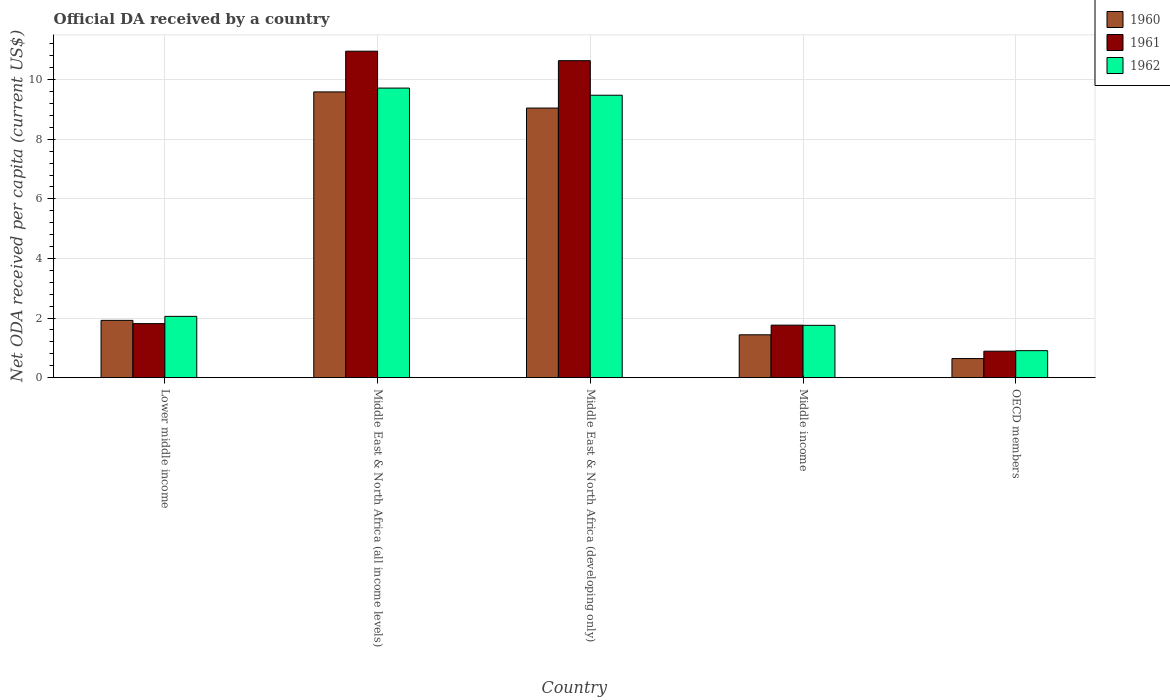How many groups of bars are there?
Ensure brevity in your answer.  5. Are the number of bars per tick equal to the number of legend labels?
Offer a very short reply. Yes. How many bars are there on the 3rd tick from the left?
Give a very brief answer. 3. What is the label of the 1st group of bars from the left?
Provide a succinct answer. Lower middle income. What is the ODA received in in 1961 in Middle East & North Africa (developing only)?
Ensure brevity in your answer.  10.64. Across all countries, what is the maximum ODA received in in 1962?
Provide a short and direct response. 9.72. Across all countries, what is the minimum ODA received in in 1961?
Ensure brevity in your answer.  0.89. In which country was the ODA received in in 1961 maximum?
Provide a succinct answer. Middle East & North Africa (all income levels). In which country was the ODA received in in 1961 minimum?
Your response must be concise. OECD members. What is the total ODA received in in 1962 in the graph?
Offer a terse response. 23.92. What is the difference between the ODA received in in 1960 in Middle East & North Africa (all income levels) and that in Middle income?
Your answer should be compact. 8.15. What is the difference between the ODA received in in 1962 in Middle income and the ODA received in in 1961 in Middle East & North Africa (all income levels)?
Ensure brevity in your answer.  -9.2. What is the average ODA received in in 1961 per country?
Your response must be concise. 5.21. What is the difference between the ODA received in of/in 1961 and ODA received in of/in 1960 in Lower middle income?
Offer a very short reply. -0.11. What is the ratio of the ODA received in in 1961 in Middle East & North Africa (all income levels) to that in Middle income?
Offer a terse response. 6.22. Is the ODA received in in 1961 in Middle East & North Africa (all income levels) less than that in OECD members?
Provide a short and direct response. No. What is the difference between the highest and the second highest ODA received in in 1960?
Provide a succinct answer. 7.67. What is the difference between the highest and the lowest ODA received in in 1961?
Offer a terse response. 10.07. What does the 3rd bar from the right in Middle East & North Africa (all income levels) represents?
Give a very brief answer. 1960. Is it the case that in every country, the sum of the ODA received in in 1960 and ODA received in in 1962 is greater than the ODA received in in 1961?
Your response must be concise. Yes. How many bars are there?
Your answer should be compact. 15. What is the difference between two consecutive major ticks on the Y-axis?
Your response must be concise. 2. Are the values on the major ticks of Y-axis written in scientific E-notation?
Keep it short and to the point. No. Does the graph contain any zero values?
Provide a succinct answer. No. Does the graph contain grids?
Your answer should be very brief. Yes. How many legend labels are there?
Give a very brief answer. 3. How are the legend labels stacked?
Your response must be concise. Vertical. What is the title of the graph?
Ensure brevity in your answer.  Official DA received by a country. What is the label or title of the X-axis?
Your response must be concise. Country. What is the label or title of the Y-axis?
Your answer should be compact. Net ODA received per capita (current US$). What is the Net ODA received per capita (current US$) in 1960 in Lower middle income?
Give a very brief answer. 1.92. What is the Net ODA received per capita (current US$) in 1961 in Lower middle income?
Provide a short and direct response. 1.81. What is the Net ODA received per capita (current US$) in 1962 in Lower middle income?
Provide a short and direct response. 2.06. What is the Net ODA received per capita (current US$) in 1960 in Middle East & North Africa (all income levels)?
Your answer should be compact. 9.59. What is the Net ODA received per capita (current US$) of 1961 in Middle East & North Africa (all income levels)?
Offer a very short reply. 10.96. What is the Net ODA received per capita (current US$) in 1962 in Middle East & North Africa (all income levels)?
Offer a terse response. 9.72. What is the Net ODA received per capita (current US$) in 1960 in Middle East & North Africa (developing only)?
Give a very brief answer. 9.05. What is the Net ODA received per capita (current US$) in 1961 in Middle East & North Africa (developing only)?
Provide a succinct answer. 10.64. What is the Net ODA received per capita (current US$) in 1962 in Middle East & North Africa (developing only)?
Provide a short and direct response. 9.48. What is the Net ODA received per capita (current US$) of 1960 in Middle income?
Ensure brevity in your answer.  1.44. What is the Net ODA received per capita (current US$) of 1961 in Middle income?
Give a very brief answer. 1.76. What is the Net ODA received per capita (current US$) in 1962 in Middle income?
Ensure brevity in your answer.  1.76. What is the Net ODA received per capita (current US$) in 1960 in OECD members?
Keep it short and to the point. 0.64. What is the Net ODA received per capita (current US$) in 1961 in OECD members?
Your answer should be compact. 0.89. What is the Net ODA received per capita (current US$) in 1962 in OECD members?
Offer a terse response. 0.91. Across all countries, what is the maximum Net ODA received per capita (current US$) of 1960?
Keep it short and to the point. 9.59. Across all countries, what is the maximum Net ODA received per capita (current US$) of 1961?
Provide a succinct answer. 10.96. Across all countries, what is the maximum Net ODA received per capita (current US$) of 1962?
Give a very brief answer. 9.72. Across all countries, what is the minimum Net ODA received per capita (current US$) of 1960?
Offer a terse response. 0.64. Across all countries, what is the minimum Net ODA received per capita (current US$) in 1961?
Ensure brevity in your answer.  0.89. Across all countries, what is the minimum Net ODA received per capita (current US$) of 1962?
Give a very brief answer. 0.91. What is the total Net ODA received per capita (current US$) in 1960 in the graph?
Offer a very short reply. 22.64. What is the total Net ODA received per capita (current US$) of 1961 in the graph?
Keep it short and to the point. 26.06. What is the total Net ODA received per capita (current US$) in 1962 in the graph?
Provide a short and direct response. 23.92. What is the difference between the Net ODA received per capita (current US$) of 1960 in Lower middle income and that in Middle East & North Africa (all income levels)?
Your answer should be very brief. -7.67. What is the difference between the Net ODA received per capita (current US$) in 1961 in Lower middle income and that in Middle East & North Africa (all income levels)?
Offer a very short reply. -9.14. What is the difference between the Net ODA received per capita (current US$) in 1962 in Lower middle income and that in Middle East & North Africa (all income levels)?
Your response must be concise. -7.66. What is the difference between the Net ODA received per capita (current US$) in 1960 in Lower middle income and that in Middle East & North Africa (developing only)?
Your answer should be compact. -7.13. What is the difference between the Net ODA received per capita (current US$) in 1961 in Lower middle income and that in Middle East & North Africa (developing only)?
Provide a short and direct response. -8.82. What is the difference between the Net ODA received per capita (current US$) in 1962 in Lower middle income and that in Middle East & North Africa (developing only)?
Your response must be concise. -7.42. What is the difference between the Net ODA received per capita (current US$) in 1960 in Lower middle income and that in Middle income?
Your answer should be very brief. 0.48. What is the difference between the Net ODA received per capita (current US$) in 1961 in Lower middle income and that in Middle income?
Offer a terse response. 0.05. What is the difference between the Net ODA received per capita (current US$) in 1962 in Lower middle income and that in Middle income?
Provide a succinct answer. 0.3. What is the difference between the Net ODA received per capita (current US$) of 1960 in Lower middle income and that in OECD members?
Keep it short and to the point. 1.28. What is the difference between the Net ODA received per capita (current US$) in 1961 in Lower middle income and that in OECD members?
Make the answer very short. 0.92. What is the difference between the Net ODA received per capita (current US$) in 1962 in Lower middle income and that in OECD members?
Make the answer very short. 1.15. What is the difference between the Net ODA received per capita (current US$) of 1960 in Middle East & North Africa (all income levels) and that in Middle East & North Africa (developing only)?
Ensure brevity in your answer.  0.54. What is the difference between the Net ODA received per capita (current US$) in 1961 in Middle East & North Africa (all income levels) and that in Middle East & North Africa (developing only)?
Offer a very short reply. 0.32. What is the difference between the Net ODA received per capita (current US$) in 1962 in Middle East & North Africa (all income levels) and that in Middle East & North Africa (developing only)?
Offer a terse response. 0.24. What is the difference between the Net ODA received per capita (current US$) of 1960 in Middle East & North Africa (all income levels) and that in Middle income?
Offer a very short reply. 8.15. What is the difference between the Net ODA received per capita (current US$) in 1961 in Middle East & North Africa (all income levels) and that in Middle income?
Offer a very short reply. 9.19. What is the difference between the Net ODA received per capita (current US$) in 1962 in Middle East & North Africa (all income levels) and that in Middle income?
Provide a succinct answer. 7.96. What is the difference between the Net ODA received per capita (current US$) of 1960 in Middle East & North Africa (all income levels) and that in OECD members?
Give a very brief answer. 8.95. What is the difference between the Net ODA received per capita (current US$) in 1961 in Middle East & North Africa (all income levels) and that in OECD members?
Ensure brevity in your answer.  10.07. What is the difference between the Net ODA received per capita (current US$) in 1962 in Middle East & North Africa (all income levels) and that in OECD members?
Offer a terse response. 8.81. What is the difference between the Net ODA received per capita (current US$) in 1960 in Middle East & North Africa (developing only) and that in Middle income?
Your answer should be very brief. 7.61. What is the difference between the Net ODA received per capita (current US$) of 1961 in Middle East & North Africa (developing only) and that in Middle income?
Give a very brief answer. 8.88. What is the difference between the Net ODA received per capita (current US$) of 1962 in Middle East & North Africa (developing only) and that in Middle income?
Offer a terse response. 7.72. What is the difference between the Net ODA received per capita (current US$) of 1960 in Middle East & North Africa (developing only) and that in OECD members?
Your answer should be compact. 8.41. What is the difference between the Net ODA received per capita (current US$) in 1961 in Middle East & North Africa (developing only) and that in OECD members?
Your answer should be very brief. 9.75. What is the difference between the Net ODA received per capita (current US$) of 1962 in Middle East & North Africa (developing only) and that in OECD members?
Your answer should be very brief. 8.57. What is the difference between the Net ODA received per capita (current US$) in 1960 in Middle income and that in OECD members?
Keep it short and to the point. 0.8. What is the difference between the Net ODA received per capita (current US$) of 1961 in Middle income and that in OECD members?
Your response must be concise. 0.87. What is the difference between the Net ODA received per capita (current US$) in 1962 in Middle income and that in OECD members?
Provide a succinct answer. 0.85. What is the difference between the Net ODA received per capita (current US$) of 1960 in Lower middle income and the Net ODA received per capita (current US$) of 1961 in Middle East & North Africa (all income levels)?
Make the answer very short. -9.03. What is the difference between the Net ODA received per capita (current US$) in 1960 in Lower middle income and the Net ODA received per capita (current US$) in 1962 in Middle East & North Africa (all income levels)?
Keep it short and to the point. -7.8. What is the difference between the Net ODA received per capita (current US$) of 1961 in Lower middle income and the Net ODA received per capita (current US$) of 1962 in Middle East & North Africa (all income levels)?
Offer a terse response. -7.9. What is the difference between the Net ODA received per capita (current US$) in 1960 in Lower middle income and the Net ODA received per capita (current US$) in 1961 in Middle East & North Africa (developing only)?
Make the answer very short. -8.72. What is the difference between the Net ODA received per capita (current US$) in 1960 in Lower middle income and the Net ODA received per capita (current US$) in 1962 in Middle East & North Africa (developing only)?
Provide a short and direct response. -7.56. What is the difference between the Net ODA received per capita (current US$) of 1961 in Lower middle income and the Net ODA received per capita (current US$) of 1962 in Middle East & North Africa (developing only)?
Make the answer very short. -7.67. What is the difference between the Net ODA received per capita (current US$) of 1960 in Lower middle income and the Net ODA received per capita (current US$) of 1961 in Middle income?
Your response must be concise. 0.16. What is the difference between the Net ODA received per capita (current US$) of 1960 in Lower middle income and the Net ODA received per capita (current US$) of 1962 in Middle income?
Provide a succinct answer. 0.17. What is the difference between the Net ODA received per capita (current US$) of 1961 in Lower middle income and the Net ODA received per capita (current US$) of 1962 in Middle income?
Provide a short and direct response. 0.06. What is the difference between the Net ODA received per capita (current US$) of 1960 in Lower middle income and the Net ODA received per capita (current US$) of 1961 in OECD members?
Your answer should be very brief. 1.03. What is the difference between the Net ODA received per capita (current US$) in 1960 in Lower middle income and the Net ODA received per capita (current US$) in 1962 in OECD members?
Give a very brief answer. 1.02. What is the difference between the Net ODA received per capita (current US$) of 1961 in Lower middle income and the Net ODA received per capita (current US$) of 1962 in OECD members?
Make the answer very short. 0.91. What is the difference between the Net ODA received per capita (current US$) in 1960 in Middle East & North Africa (all income levels) and the Net ODA received per capita (current US$) in 1961 in Middle East & North Africa (developing only)?
Make the answer very short. -1.05. What is the difference between the Net ODA received per capita (current US$) in 1960 in Middle East & North Africa (all income levels) and the Net ODA received per capita (current US$) in 1962 in Middle East & North Africa (developing only)?
Offer a terse response. 0.11. What is the difference between the Net ODA received per capita (current US$) of 1961 in Middle East & North Africa (all income levels) and the Net ODA received per capita (current US$) of 1962 in Middle East & North Africa (developing only)?
Make the answer very short. 1.48. What is the difference between the Net ODA received per capita (current US$) in 1960 in Middle East & North Africa (all income levels) and the Net ODA received per capita (current US$) in 1961 in Middle income?
Make the answer very short. 7.83. What is the difference between the Net ODA received per capita (current US$) of 1960 in Middle East & North Africa (all income levels) and the Net ODA received per capita (current US$) of 1962 in Middle income?
Make the answer very short. 7.83. What is the difference between the Net ODA received per capita (current US$) of 1961 in Middle East & North Africa (all income levels) and the Net ODA received per capita (current US$) of 1962 in Middle income?
Offer a terse response. 9.2. What is the difference between the Net ODA received per capita (current US$) of 1960 in Middle East & North Africa (all income levels) and the Net ODA received per capita (current US$) of 1961 in OECD members?
Give a very brief answer. 8.7. What is the difference between the Net ODA received per capita (current US$) of 1960 in Middle East & North Africa (all income levels) and the Net ODA received per capita (current US$) of 1962 in OECD members?
Ensure brevity in your answer.  8.68. What is the difference between the Net ODA received per capita (current US$) of 1961 in Middle East & North Africa (all income levels) and the Net ODA received per capita (current US$) of 1962 in OECD members?
Your response must be concise. 10.05. What is the difference between the Net ODA received per capita (current US$) of 1960 in Middle East & North Africa (developing only) and the Net ODA received per capita (current US$) of 1961 in Middle income?
Give a very brief answer. 7.29. What is the difference between the Net ODA received per capita (current US$) in 1960 in Middle East & North Africa (developing only) and the Net ODA received per capita (current US$) in 1962 in Middle income?
Your response must be concise. 7.29. What is the difference between the Net ODA received per capita (current US$) in 1961 in Middle East & North Africa (developing only) and the Net ODA received per capita (current US$) in 1962 in Middle income?
Make the answer very short. 8.88. What is the difference between the Net ODA received per capita (current US$) of 1960 in Middle East & North Africa (developing only) and the Net ODA received per capita (current US$) of 1961 in OECD members?
Provide a succinct answer. 8.16. What is the difference between the Net ODA received per capita (current US$) of 1960 in Middle East & North Africa (developing only) and the Net ODA received per capita (current US$) of 1962 in OECD members?
Offer a very short reply. 8.14. What is the difference between the Net ODA received per capita (current US$) in 1961 in Middle East & North Africa (developing only) and the Net ODA received per capita (current US$) in 1962 in OECD members?
Give a very brief answer. 9.73. What is the difference between the Net ODA received per capita (current US$) of 1960 in Middle income and the Net ODA received per capita (current US$) of 1961 in OECD members?
Provide a short and direct response. 0.55. What is the difference between the Net ODA received per capita (current US$) in 1960 in Middle income and the Net ODA received per capita (current US$) in 1962 in OECD members?
Make the answer very short. 0.53. What is the difference between the Net ODA received per capita (current US$) in 1961 in Middle income and the Net ODA received per capita (current US$) in 1962 in OECD members?
Make the answer very short. 0.86. What is the average Net ODA received per capita (current US$) in 1960 per country?
Provide a succinct answer. 4.53. What is the average Net ODA received per capita (current US$) in 1961 per country?
Your answer should be compact. 5.21. What is the average Net ODA received per capita (current US$) of 1962 per country?
Make the answer very short. 4.78. What is the difference between the Net ODA received per capita (current US$) in 1960 and Net ODA received per capita (current US$) in 1961 in Lower middle income?
Your response must be concise. 0.11. What is the difference between the Net ODA received per capita (current US$) in 1960 and Net ODA received per capita (current US$) in 1962 in Lower middle income?
Offer a terse response. -0.13. What is the difference between the Net ODA received per capita (current US$) of 1961 and Net ODA received per capita (current US$) of 1962 in Lower middle income?
Offer a very short reply. -0.24. What is the difference between the Net ODA received per capita (current US$) of 1960 and Net ODA received per capita (current US$) of 1961 in Middle East & North Africa (all income levels)?
Provide a short and direct response. -1.37. What is the difference between the Net ODA received per capita (current US$) in 1960 and Net ODA received per capita (current US$) in 1962 in Middle East & North Africa (all income levels)?
Give a very brief answer. -0.13. What is the difference between the Net ODA received per capita (current US$) in 1961 and Net ODA received per capita (current US$) in 1962 in Middle East & North Africa (all income levels)?
Make the answer very short. 1.24. What is the difference between the Net ODA received per capita (current US$) of 1960 and Net ODA received per capita (current US$) of 1961 in Middle East & North Africa (developing only)?
Provide a succinct answer. -1.59. What is the difference between the Net ODA received per capita (current US$) in 1960 and Net ODA received per capita (current US$) in 1962 in Middle East & North Africa (developing only)?
Your answer should be very brief. -0.43. What is the difference between the Net ODA received per capita (current US$) of 1961 and Net ODA received per capita (current US$) of 1962 in Middle East & North Africa (developing only)?
Your answer should be very brief. 1.16. What is the difference between the Net ODA received per capita (current US$) of 1960 and Net ODA received per capita (current US$) of 1961 in Middle income?
Make the answer very short. -0.32. What is the difference between the Net ODA received per capita (current US$) of 1960 and Net ODA received per capita (current US$) of 1962 in Middle income?
Offer a very short reply. -0.32. What is the difference between the Net ODA received per capita (current US$) in 1961 and Net ODA received per capita (current US$) in 1962 in Middle income?
Give a very brief answer. 0.01. What is the difference between the Net ODA received per capita (current US$) of 1960 and Net ODA received per capita (current US$) of 1961 in OECD members?
Offer a very short reply. -0.25. What is the difference between the Net ODA received per capita (current US$) in 1960 and Net ODA received per capita (current US$) in 1962 in OECD members?
Make the answer very short. -0.27. What is the difference between the Net ODA received per capita (current US$) of 1961 and Net ODA received per capita (current US$) of 1962 in OECD members?
Make the answer very short. -0.02. What is the ratio of the Net ODA received per capita (current US$) in 1960 in Lower middle income to that in Middle East & North Africa (all income levels)?
Provide a short and direct response. 0.2. What is the ratio of the Net ODA received per capita (current US$) of 1961 in Lower middle income to that in Middle East & North Africa (all income levels)?
Your response must be concise. 0.17. What is the ratio of the Net ODA received per capita (current US$) of 1962 in Lower middle income to that in Middle East & North Africa (all income levels)?
Your response must be concise. 0.21. What is the ratio of the Net ODA received per capita (current US$) of 1960 in Lower middle income to that in Middle East & North Africa (developing only)?
Give a very brief answer. 0.21. What is the ratio of the Net ODA received per capita (current US$) in 1961 in Lower middle income to that in Middle East & North Africa (developing only)?
Your answer should be very brief. 0.17. What is the ratio of the Net ODA received per capita (current US$) of 1962 in Lower middle income to that in Middle East & North Africa (developing only)?
Ensure brevity in your answer.  0.22. What is the ratio of the Net ODA received per capita (current US$) of 1960 in Lower middle income to that in Middle income?
Give a very brief answer. 1.34. What is the ratio of the Net ODA received per capita (current US$) in 1961 in Lower middle income to that in Middle income?
Give a very brief answer. 1.03. What is the ratio of the Net ODA received per capita (current US$) of 1962 in Lower middle income to that in Middle income?
Make the answer very short. 1.17. What is the ratio of the Net ODA received per capita (current US$) in 1960 in Lower middle income to that in OECD members?
Ensure brevity in your answer.  3. What is the ratio of the Net ODA received per capita (current US$) of 1961 in Lower middle income to that in OECD members?
Give a very brief answer. 2.04. What is the ratio of the Net ODA received per capita (current US$) of 1962 in Lower middle income to that in OECD members?
Make the answer very short. 2.27. What is the ratio of the Net ODA received per capita (current US$) of 1960 in Middle East & North Africa (all income levels) to that in Middle East & North Africa (developing only)?
Your answer should be very brief. 1.06. What is the ratio of the Net ODA received per capita (current US$) in 1961 in Middle East & North Africa (all income levels) to that in Middle East & North Africa (developing only)?
Keep it short and to the point. 1.03. What is the ratio of the Net ODA received per capita (current US$) in 1962 in Middle East & North Africa (all income levels) to that in Middle East & North Africa (developing only)?
Provide a succinct answer. 1.03. What is the ratio of the Net ODA received per capita (current US$) of 1960 in Middle East & North Africa (all income levels) to that in Middle income?
Provide a short and direct response. 6.67. What is the ratio of the Net ODA received per capita (current US$) of 1961 in Middle East & North Africa (all income levels) to that in Middle income?
Your answer should be compact. 6.22. What is the ratio of the Net ODA received per capita (current US$) of 1962 in Middle East & North Africa (all income levels) to that in Middle income?
Provide a short and direct response. 5.53. What is the ratio of the Net ODA received per capita (current US$) of 1960 in Middle East & North Africa (all income levels) to that in OECD members?
Your response must be concise. 14.96. What is the ratio of the Net ODA received per capita (current US$) in 1961 in Middle East & North Africa (all income levels) to that in OECD members?
Your response must be concise. 12.33. What is the ratio of the Net ODA received per capita (current US$) in 1962 in Middle East & North Africa (all income levels) to that in OECD members?
Keep it short and to the point. 10.72. What is the ratio of the Net ODA received per capita (current US$) of 1960 in Middle East & North Africa (developing only) to that in Middle income?
Offer a very short reply. 6.29. What is the ratio of the Net ODA received per capita (current US$) of 1961 in Middle East & North Africa (developing only) to that in Middle income?
Offer a terse response. 6.04. What is the ratio of the Net ODA received per capita (current US$) in 1962 in Middle East & North Africa (developing only) to that in Middle income?
Provide a short and direct response. 5.4. What is the ratio of the Net ODA received per capita (current US$) of 1960 in Middle East & North Africa (developing only) to that in OECD members?
Provide a short and direct response. 14.12. What is the ratio of the Net ODA received per capita (current US$) in 1961 in Middle East & North Africa (developing only) to that in OECD members?
Your response must be concise. 11.97. What is the ratio of the Net ODA received per capita (current US$) in 1962 in Middle East & North Africa (developing only) to that in OECD members?
Ensure brevity in your answer.  10.46. What is the ratio of the Net ODA received per capita (current US$) in 1960 in Middle income to that in OECD members?
Give a very brief answer. 2.24. What is the ratio of the Net ODA received per capita (current US$) in 1961 in Middle income to that in OECD members?
Make the answer very short. 1.98. What is the ratio of the Net ODA received per capita (current US$) of 1962 in Middle income to that in OECD members?
Your response must be concise. 1.94. What is the difference between the highest and the second highest Net ODA received per capita (current US$) in 1960?
Provide a succinct answer. 0.54. What is the difference between the highest and the second highest Net ODA received per capita (current US$) in 1961?
Offer a terse response. 0.32. What is the difference between the highest and the second highest Net ODA received per capita (current US$) of 1962?
Your answer should be very brief. 0.24. What is the difference between the highest and the lowest Net ODA received per capita (current US$) in 1960?
Offer a terse response. 8.95. What is the difference between the highest and the lowest Net ODA received per capita (current US$) of 1961?
Your answer should be very brief. 10.07. What is the difference between the highest and the lowest Net ODA received per capita (current US$) of 1962?
Offer a terse response. 8.81. 